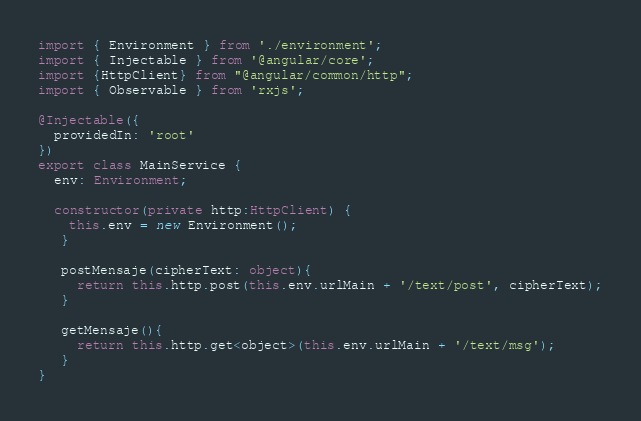Convert code to text. <code><loc_0><loc_0><loc_500><loc_500><_TypeScript_>import { Environment } from './environment';
import { Injectable } from '@angular/core';
import {HttpClient} from "@angular/common/http";
import { Observable } from 'rxjs';

@Injectable({
  providedIn: 'root'
})
export class MainService {
  env: Environment;

  constructor(private http:HttpClient) {
    this.env = new Environment();
   }

   postMensaje(cipherText: object){
     return this.http.post(this.env.urlMain + '/text/post', cipherText);
   }

   getMensaje(){
     return this.http.get<object>(this.env.urlMain + '/text/msg');
   }
}
</code> 